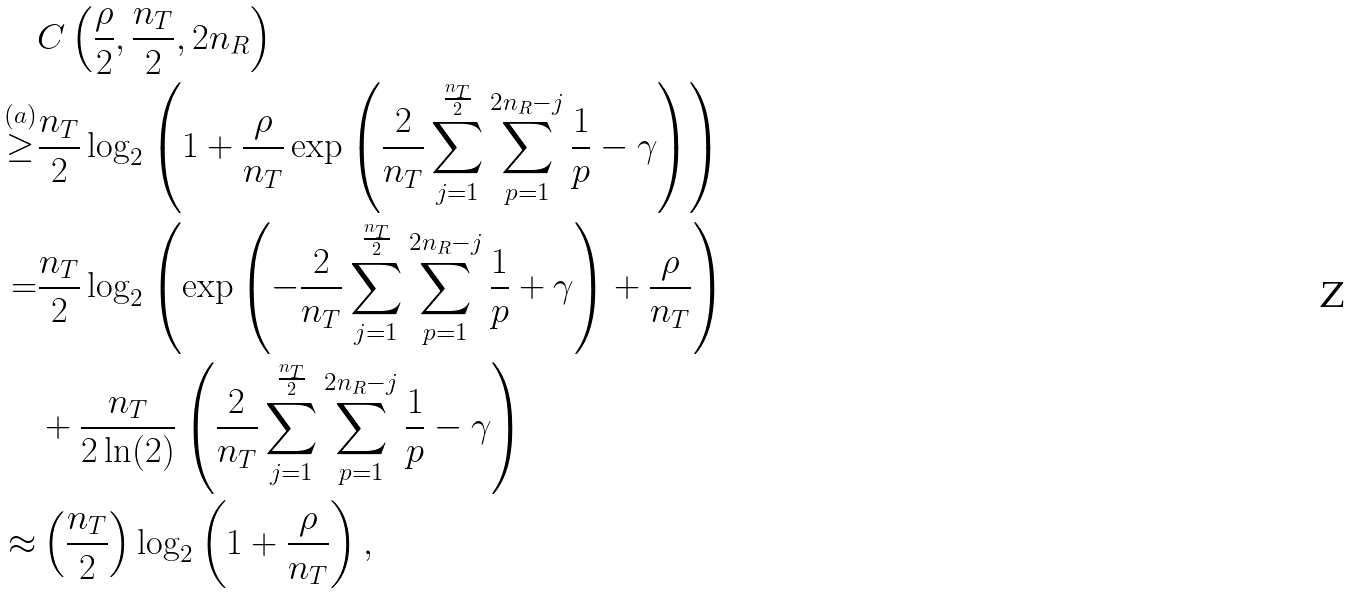Convert formula to latex. <formula><loc_0><loc_0><loc_500><loc_500>& C \left ( \frac { \rho } { 2 } , \frac { n _ { T } } { 2 } , 2 n _ { R } \right ) \\ \overset { ( a ) } { \geq } & \frac { n _ { T } } { 2 } \log _ { 2 } \left ( 1 + \frac { \rho } { n _ { T } } \exp \left ( \frac { 2 } { n _ { T } } \sum _ { j = 1 } ^ { \frac { n _ { T } } { 2 } } \sum _ { p = 1 } ^ { 2 n _ { R } - j } \frac { 1 } { p } - \gamma \right ) \right ) \\ = & \frac { n _ { T } } { 2 } \log _ { 2 } \left ( \exp \left ( - \frac { 2 } { n _ { T } } \sum _ { j = 1 } ^ { \frac { n _ { T } } { 2 } } \sum _ { p = 1 } ^ { 2 n _ { R } - j } \frac { 1 } { p } + \gamma \right ) + \frac { \rho } { n _ { T } } \right ) \\ & + \frac { n _ { T } } { 2 \ln ( 2 ) } \left ( \frac { 2 } { n _ { T } } \sum _ { j = 1 } ^ { \frac { n _ { T } } { 2 } } \sum _ { p = 1 } ^ { 2 n _ { R } - j } \frac { 1 } { p } - \gamma \right ) \\ \approx & \left ( \frac { n _ { T } } { 2 } \right ) \log _ { 2 } \left ( 1 + \frac { \rho } { n _ { T } } \right ) ,</formula> 